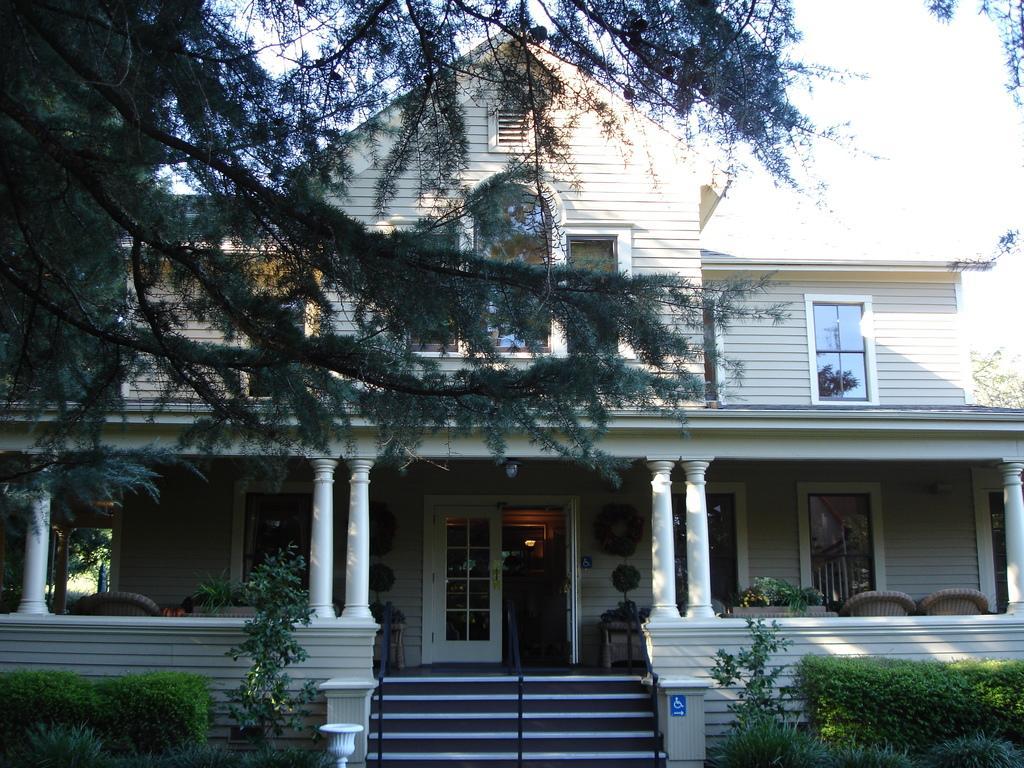Can you describe this image briefly? On the left and right side of the image I can see trees and chairs. In the middle of the image I can see stairs, building and light. 